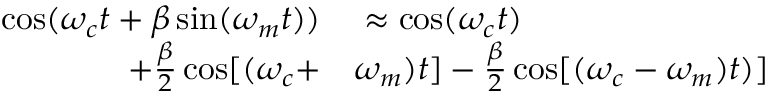Convert formula to latex. <formula><loc_0><loc_0><loc_500><loc_500>\begin{array} { r l } { \cos ( \omega _ { c } t + \beta \sin ( \omega _ { m } t ) ) } & \approx \cos ( \omega _ { c } t ) } \\ { + \frac { \beta } { 2 } \cos [ ( \omega _ { c } + } & \omega _ { m } ) t ] - \frac { \beta } { 2 } \cos [ ( \omega _ { c } - \omega _ { m } ) t ) ] } \end{array}</formula> 